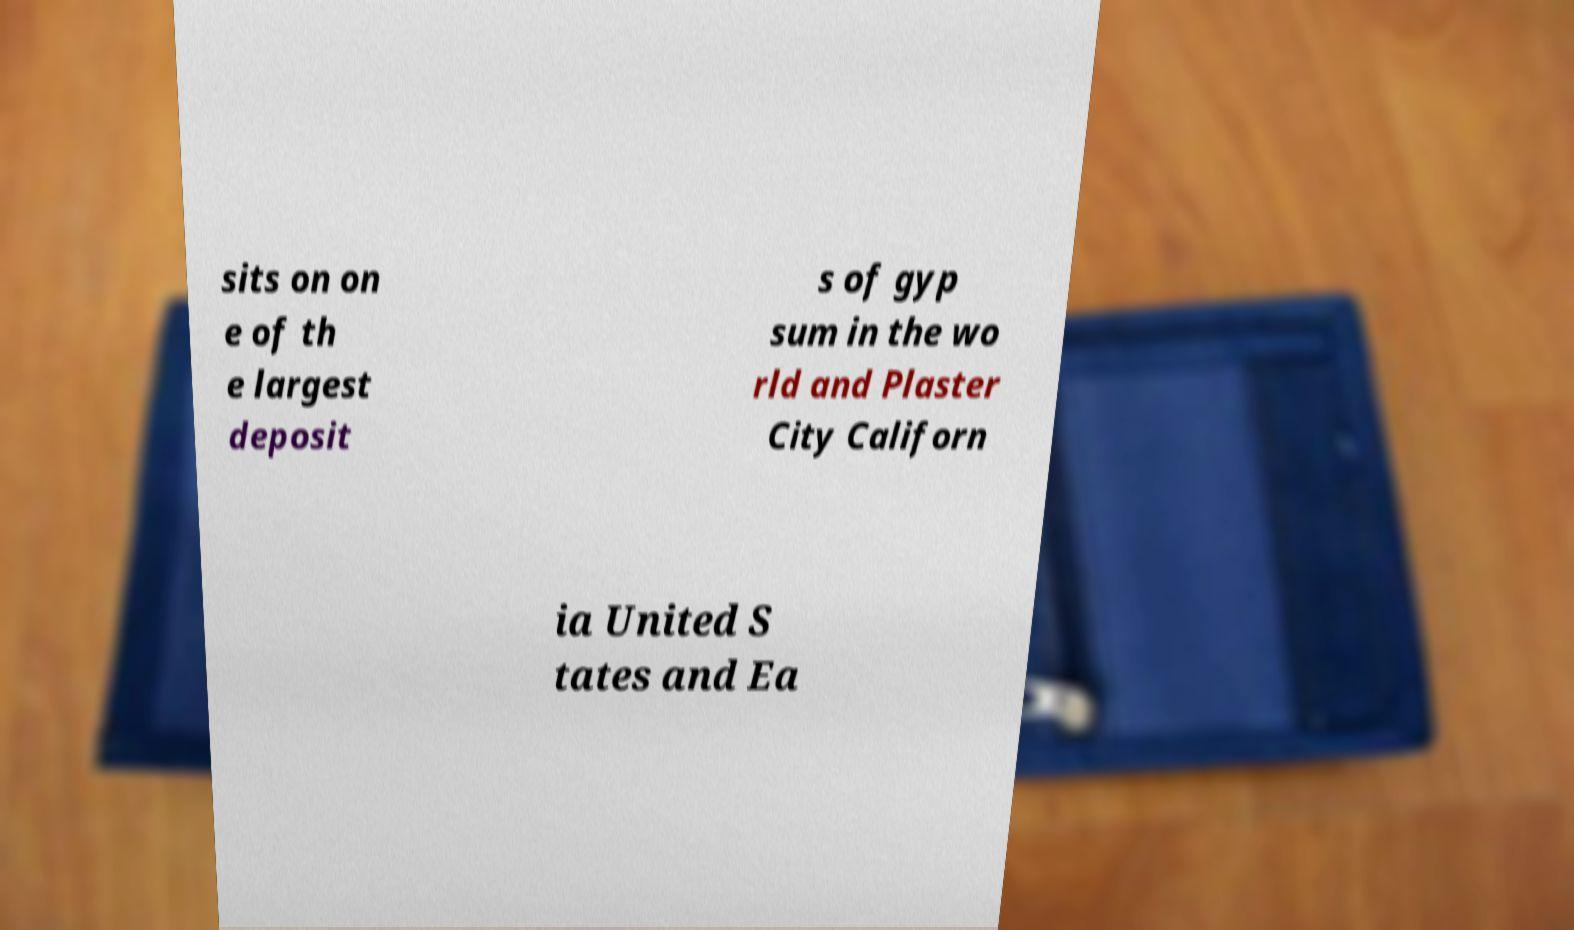Can you read and provide the text displayed in the image?This photo seems to have some interesting text. Can you extract and type it out for me? sits on on e of th e largest deposit s of gyp sum in the wo rld and Plaster City Californ ia United S tates and Ea 